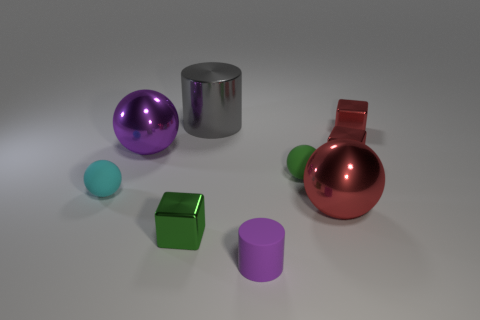The green thing right of the rubber object in front of the green cube is made of what material?
Give a very brief answer. Rubber. Is the number of small things that are behind the cyan rubber sphere greater than the number of shiny spheres?
Ensure brevity in your answer.  Yes. Is there a large red sphere?
Make the answer very short. Yes. There is a small matte sphere that is left of the gray shiny cylinder; what is its color?
Make the answer very short. Cyan. There is a green cube that is the same size as the cyan sphere; what is its material?
Make the answer very short. Metal. What number of other things are there of the same material as the purple cylinder
Ensure brevity in your answer.  2. What color is the large thing that is behind the tiny cyan rubber sphere and in front of the gray metallic thing?
Your answer should be very brief. Purple. What number of objects are either green things in front of the small cyan ball or green metal objects?
Offer a very short reply. 1. How many other things are there of the same color as the tiny cylinder?
Your response must be concise. 1. Is the number of objects in front of the cyan rubber thing the same as the number of tiny shiny blocks?
Give a very brief answer. Yes. 